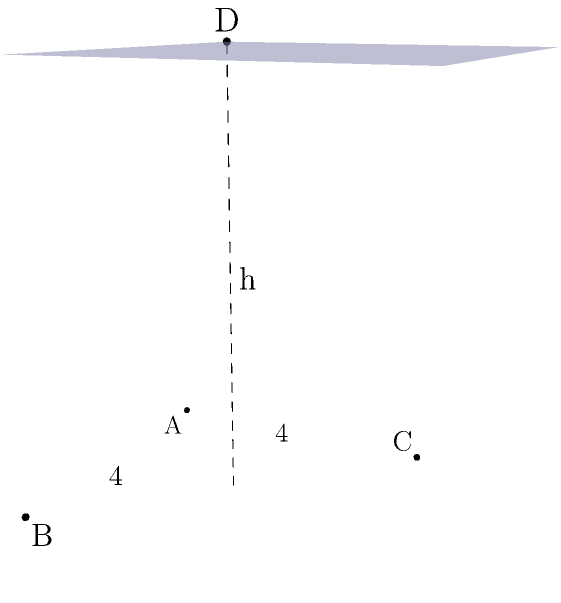A memorial structure in the shape of a pyramid is being designed to commemorate victims of the ongoing conflict. The base of the pyramid is a square with side length 4 meters, and the apex is directly above the center of the base at a height of 6 meters. Calculate the volume of this pyramid in cubic meters. To find the volume of the pyramid, we'll use the formula:

$$V = \frac{1}{3} \times B \times h$$

Where:
$V$ is the volume
$B$ is the area of the base
$h$ is the height of the pyramid

Step 1: Calculate the area of the base (B)
The base is a square with side length 4 meters.
$$B = 4 \times 4 = 16\text{ m}^2$$

Step 2: Identify the height (h)
The height is given as 6 meters.

Step 3: Apply the volume formula
$$V = \frac{1}{3} \times B \times h$$
$$V = \frac{1}{3} \times 16 \times 6$$
$$V = \frac{96}{3} = 32\text{ m}^3$$

Therefore, the volume of the pyramid-shaped memorial is 32 cubic meters.
Answer: $32\text{ m}^3$ 